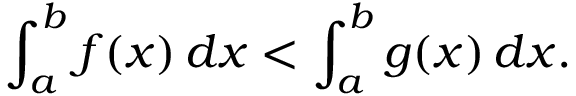Convert formula to latex. <formula><loc_0><loc_0><loc_500><loc_500>\int _ { a } ^ { b } f ( x ) \, d x < \int _ { a } ^ { b } g ( x ) \, d x .</formula> 